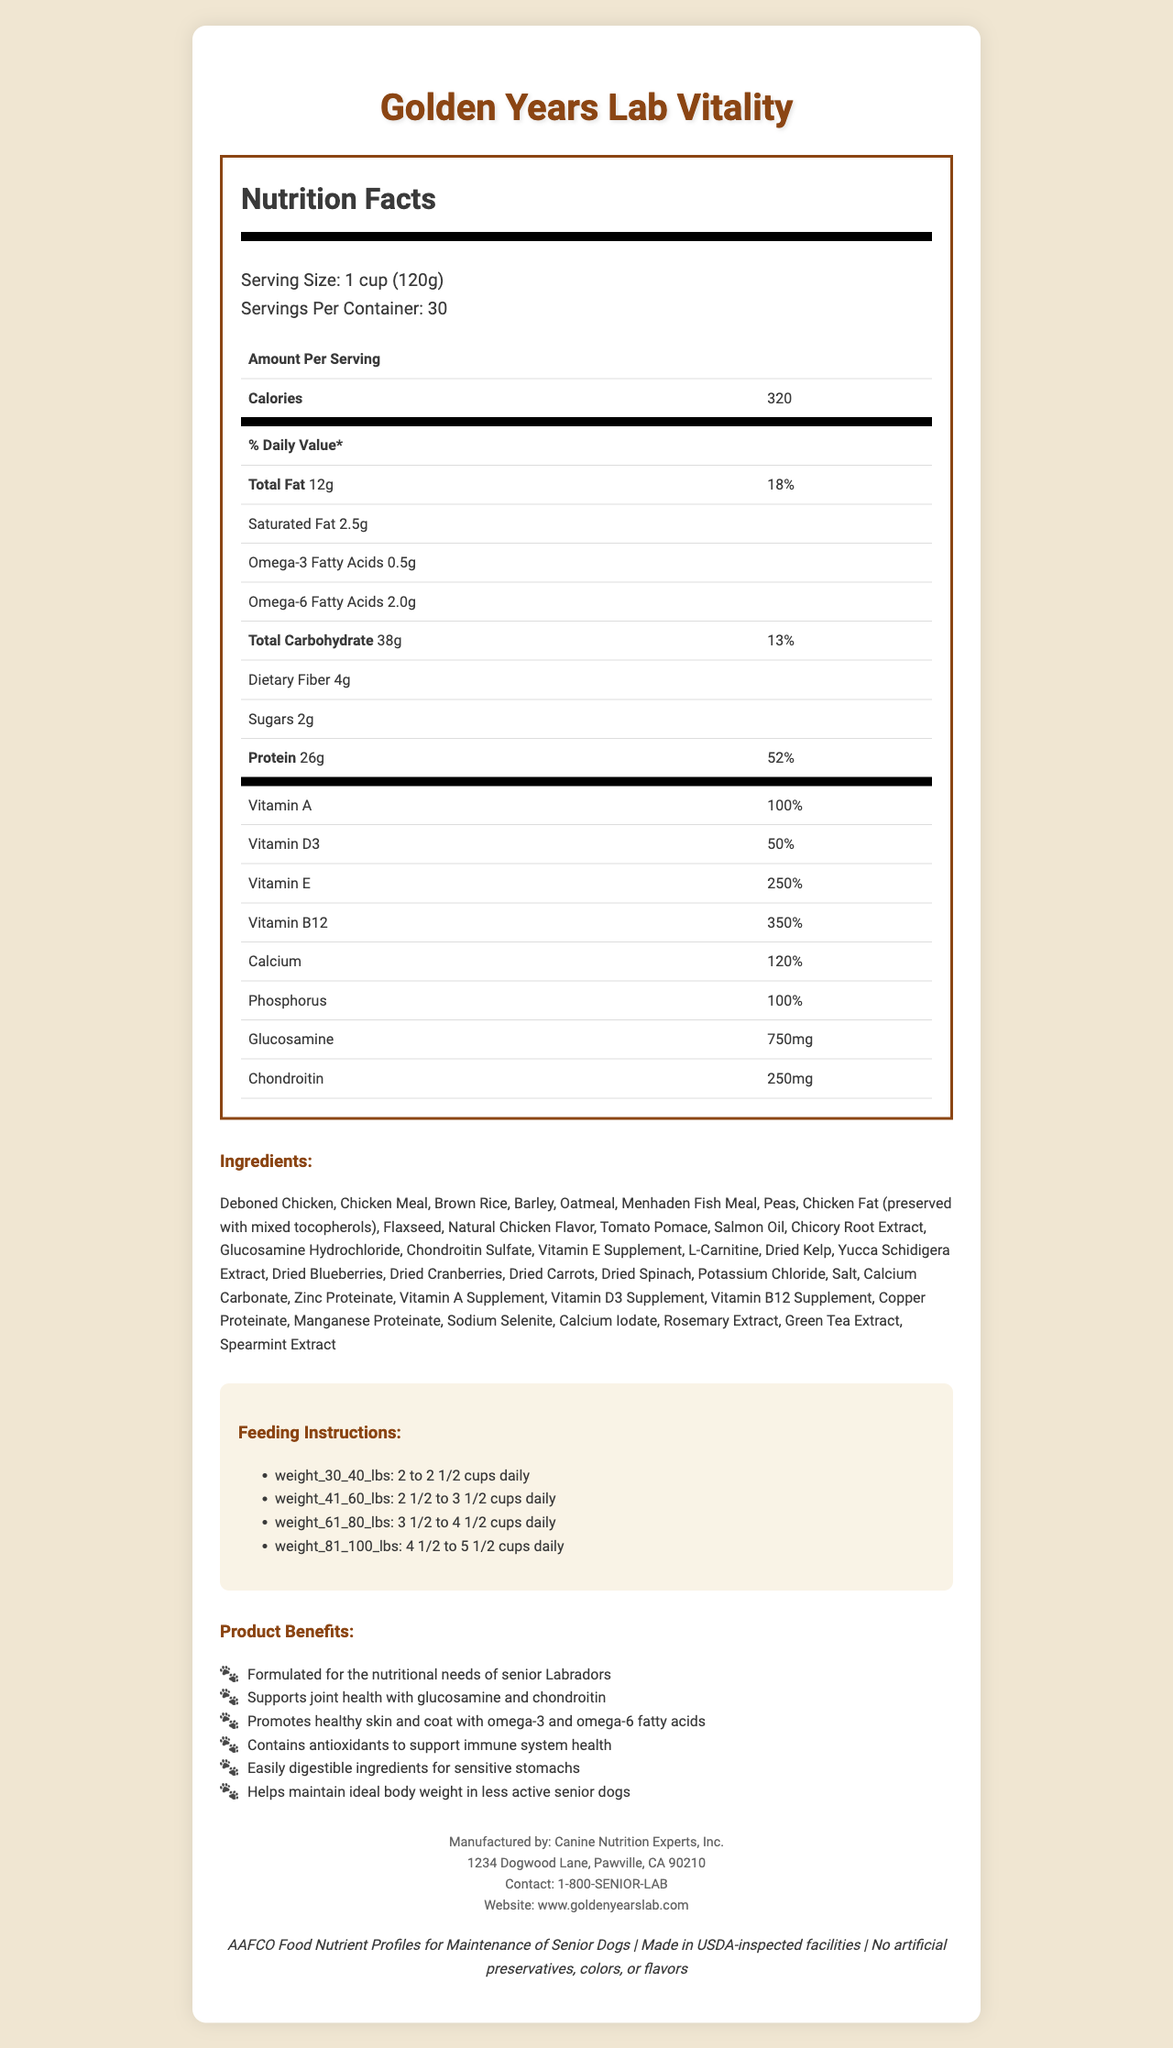what is the serving size for Golden Years Lab Vitality? The document lists the serving size as 1 cup (120g).
Answer: 1 cup (120g) how many calories are in one serving of Golden Years Lab Vitality? The document states that each serving contains 320 calories.
Answer: 320 calories how many servings are there per container? The document mentions that each container has 30 servings.
Answer: 30 servings how many grams of protein does one serving of Golden Years Lab Vitality contain? The document lists the protein content as 26 grams per serving.
Answer: 26 grams Which vitamin has the highest percent daily value per serving? A. Vitamin A B. Vitamin D3 C. Vitamin E D. Vitamin B12 The percent daily value for Vitamin B12 is 350%, which is higher than the values for Vitamins A, D3, and E.
Answer: D. Vitamin B12 how much glucosamine is in one serving of Golden Years Lab Vitality? The document states that each serving contains 750 mg of glucosamine.
Answer: 750 mg which type of fatty acids are present in this dog food? A. Omega-3 B. Omega-6 C. Both Omega-3 and Omega-6 D. Neither The document mentions that the food contains Omega-3 and Omega-6 fatty acids.
Answer: C. Both Omega-3 and Omega-6 Is there any sugar content in the dog food? The document lists sugar content as 2 grams per serving.
Answer: Yes how many feeding instructions are provided for different weight ranges? The document provides feeding instructions for four different weight ranges.
Answer: 4 weight ranges is the product made in USDA-inspected facilities? The document includes a certification stating that the product is made in USDA-inspected facilities.
Answer: Yes summarize the main idea of the document. The document outlines comprehensive nutritional details, focuses on senior Labradors, lists ingredients and feeding instructions, and highlights the product benefits, manufacturing standards, and quality certifications.
Answer: The document provides detailed nutritional information for Golden Years Lab Vitality, a premium senior dog food formulated specifically for aging Labradors. It includes serving size, calories, macronutrients, vitamins and minerals, ingredients, feeding instructions, product benefits, manufacturer information, and certifications. what is the contact number for the manufacturer? The document lists the contact number as 1-800-SENIOR-LAB.
Answer: 1-800-SENIOR-LAB how much dietary fiber is in one serving? The document states that there are 4 grams of dietary fiber per serving.
Answer: 4 grams Does the product contain artificial preservatives? The document certifies that there are no artificial preservatives, colors, or flavors included in the product.
Answer: No how many ingredients are listed before "Flaxseed"? The ingredients listed before "Flaxseed" are Deboned Chicken, Chicken Meal, Brown Rice, Barley, Oatmeal, Menhaden Fish Meal, and Peas, totaling 7 ingredients.
Answer: 7 ingredients who manufactures Golden Years Lab Vitality? The document specifies that Canine Nutrition Experts, Inc. is the manufacturer.
Answer: Canine Nutrition Experts, Inc. how many vitamins and minerals have a percent daily value of 100% or higher? The vitamins and minerals with a percent daily value of 100% or higher are Vitamin A (100%), Vitamin D3 (50%), Vitamin E (250%), Vitamin B12 (350%), and Calcium (120%).
Answer: 5 vitamins and minerals what is the address of the manufacturer? The document lists the manufacturer's address as 1234 Dogwood Lane, Pawville, CA 90210.
Answer: 1234 Dogwood Lane, Pawville, CA 90210 describe one of the product benefits related to digestive health. The document states that one of the product benefits is its easily digestible ingredients, which are suitable for sensitive stomachs.
Answer: Easily digestible ingredients for sensitive stomachs Which certification can not be determined through the document? The document provides all the necessary certifications directly, but any certifications beyond those listed cannot be determined just by the available information.
Answer: I don't know 